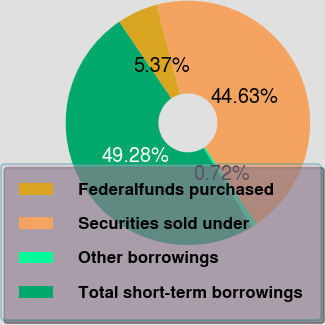Convert chart to OTSL. <chart><loc_0><loc_0><loc_500><loc_500><pie_chart><fcel>Federalfunds purchased<fcel>Securities sold under<fcel>Other borrowings<fcel>Total short-term borrowings<nl><fcel>5.37%<fcel>44.63%<fcel>0.72%<fcel>49.28%<nl></chart> 